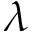<formula> <loc_0><loc_0><loc_500><loc_500>\lambda</formula> 